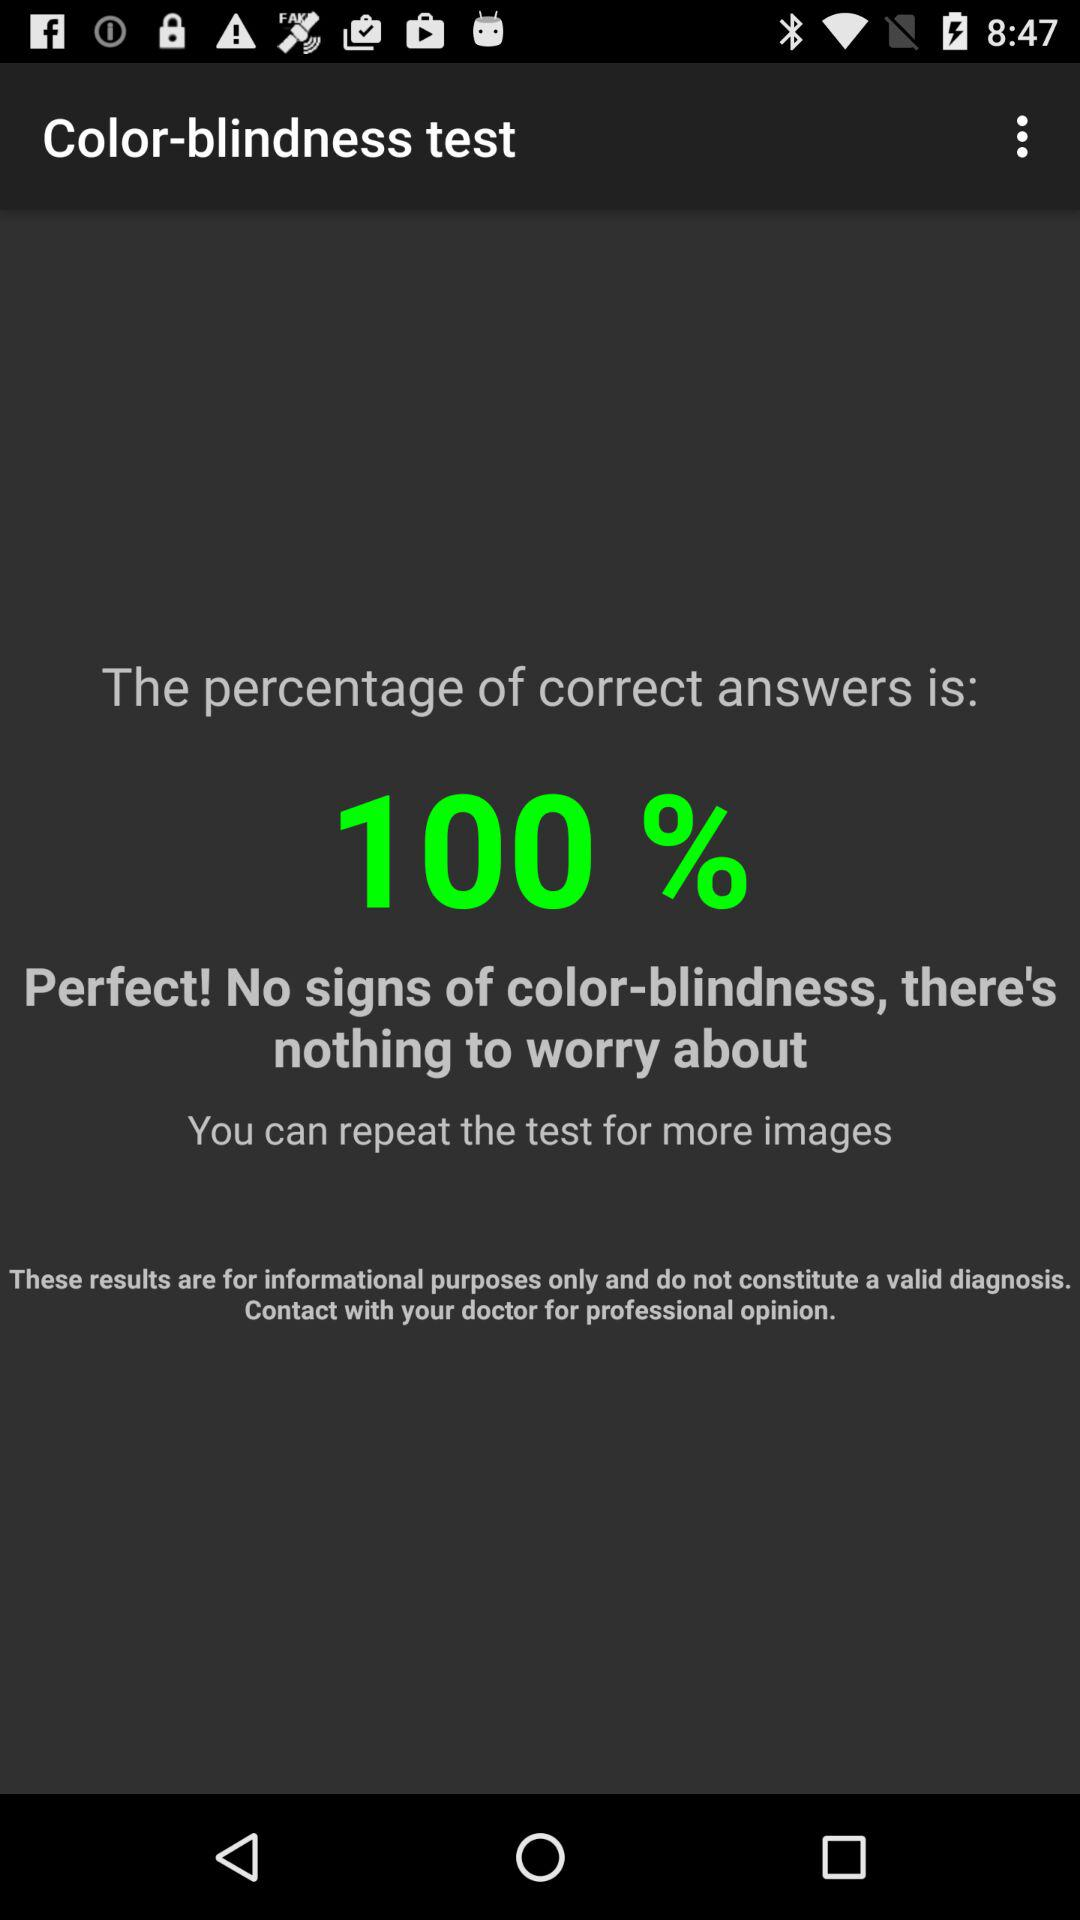What is the score of the color-blindness test? The score is 100%. 